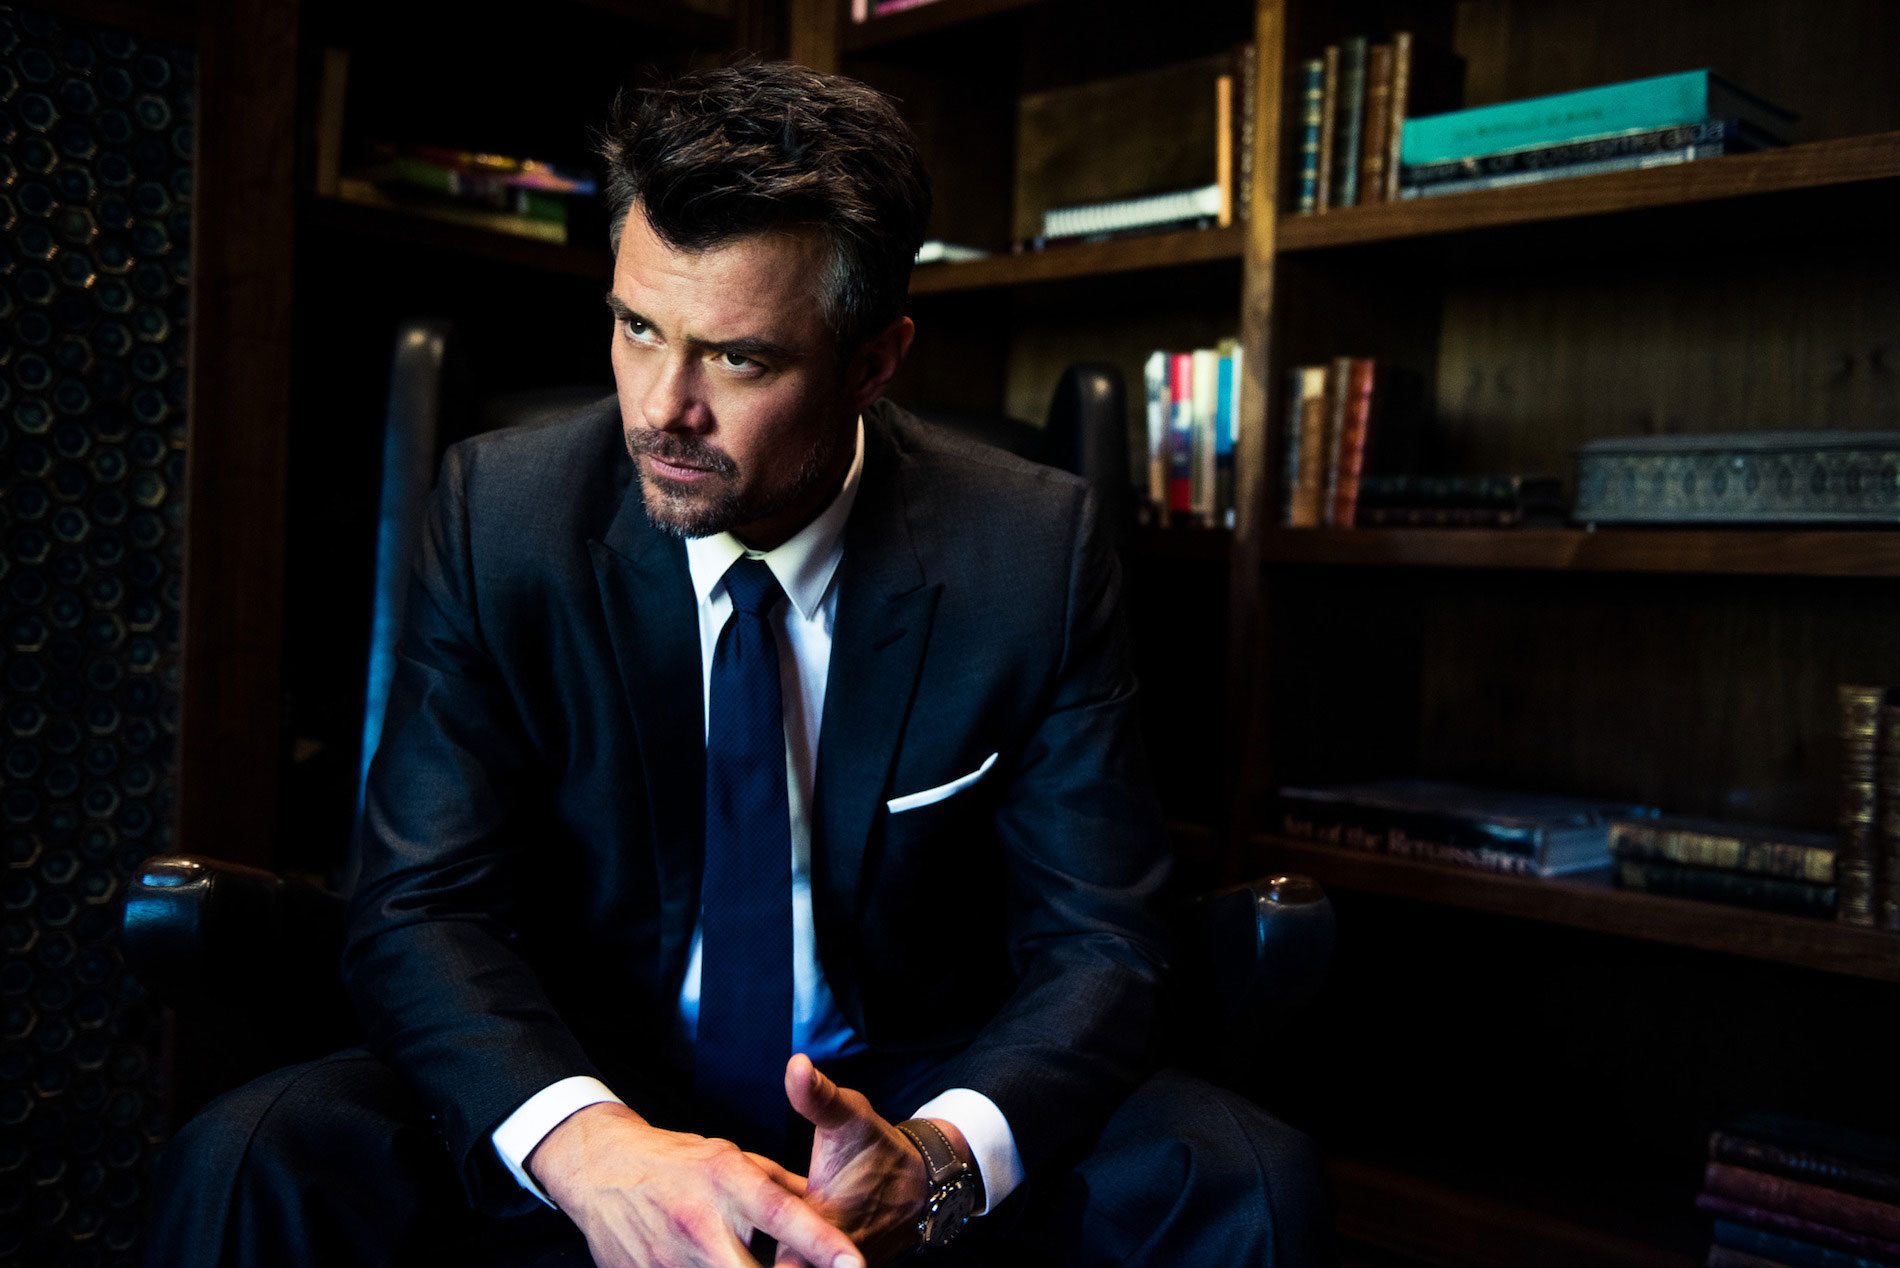What do you see happening in this image? In this image, we see a man who appears to be deep in thought. He's seated in a dark blue armchair, in front of a bookshelf filled with various books and decorative objects. He is dressed formally in a black suit and tie, suggesting a professional or serious context. His hair is styled in a slightly messy yet professional manner, further emphasizing the nuanced setting. He has his hands clasped together and is gazing off to the side, which adds to the contemplative mood, complemented by the dim lighting that creates a somber atmosphere. 